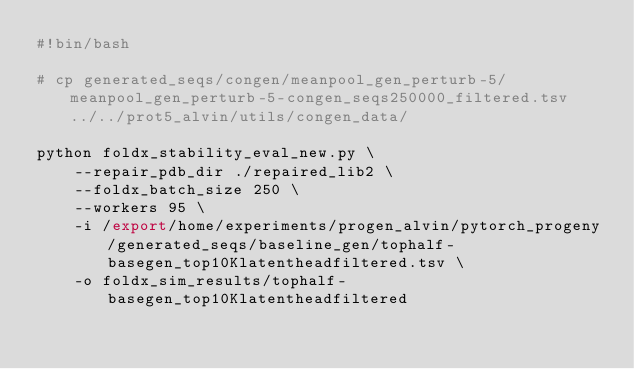<code> <loc_0><loc_0><loc_500><loc_500><_Bash_>#!bin/bash

# cp generated_seqs/congen/meanpool_gen_perturb-5/meanpool_gen_perturb-5-congen_seqs250000_filtered.tsv ../../prot5_alvin/utils/congen_data/

python foldx_stability_eval_new.py \
    --repair_pdb_dir ./repaired_lib2 \
    --foldx_batch_size 250 \
    --workers 95 \
    -i /export/home/experiments/progen_alvin/pytorch_progeny/generated_seqs/baseline_gen/tophalf-basegen_top10Klatentheadfiltered.tsv \
    -o foldx_sim_results/tophalf-basegen_top10Klatentheadfiltered
</code> 